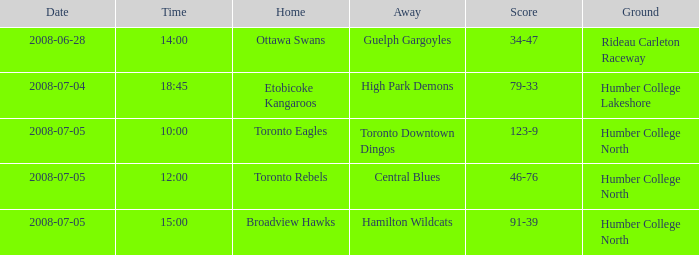What is the terrain with an away that is central blues? Humber College North. Parse the full table. {'header': ['Date', 'Time', 'Home', 'Away', 'Score', 'Ground'], 'rows': [['2008-06-28', '14:00', 'Ottawa Swans', 'Guelph Gargoyles', '34-47', 'Rideau Carleton Raceway'], ['2008-07-04', '18:45', 'Etobicoke Kangaroos', 'High Park Demons', '79-33', 'Humber College Lakeshore'], ['2008-07-05', '10:00', 'Toronto Eagles', 'Toronto Downtown Dingos', '123-9', 'Humber College North'], ['2008-07-05', '12:00', 'Toronto Rebels', 'Central Blues', '46-76', 'Humber College North'], ['2008-07-05', '15:00', 'Broadview Hawks', 'Hamilton Wildcats', '91-39', 'Humber College North']]} 